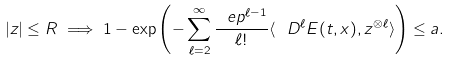<formula> <loc_0><loc_0><loc_500><loc_500>| z | \leq R \implies 1 - \exp \left ( - \sum _ { \ell = 2 } ^ { \infty } \frac { \ e p ^ { \ell - 1 } } { \ell ! } \langle \ D ^ { \ell } E ( t , x ) , z ^ { \otimes \ell } \rangle \right ) \leq a .</formula> 